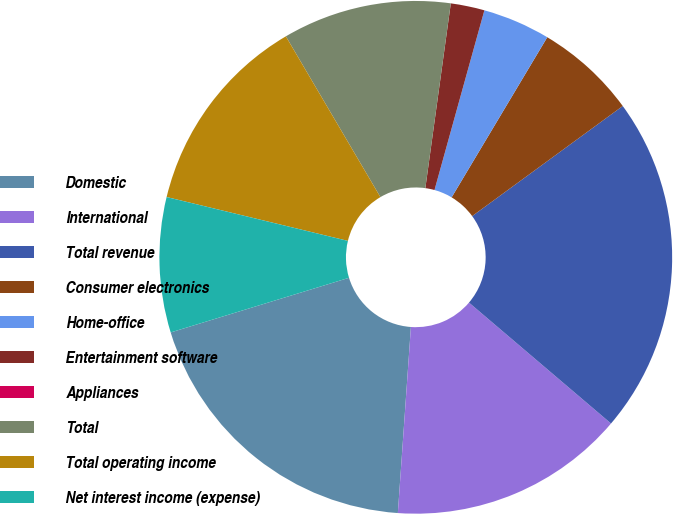Convert chart. <chart><loc_0><loc_0><loc_500><loc_500><pie_chart><fcel>Domestic<fcel>International<fcel>Total revenue<fcel>Consumer electronics<fcel>Home-office<fcel>Entertainment software<fcel>Appliances<fcel>Total<fcel>Total operating income<fcel>Net interest income (expense)<nl><fcel>19.15%<fcel>14.89%<fcel>21.27%<fcel>6.38%<fcel>4.26%<fcel>2.13%<fcel>0.0%<fcel>10.64%<fcel>12.76%<fcel>8.51%<nl></chart> 